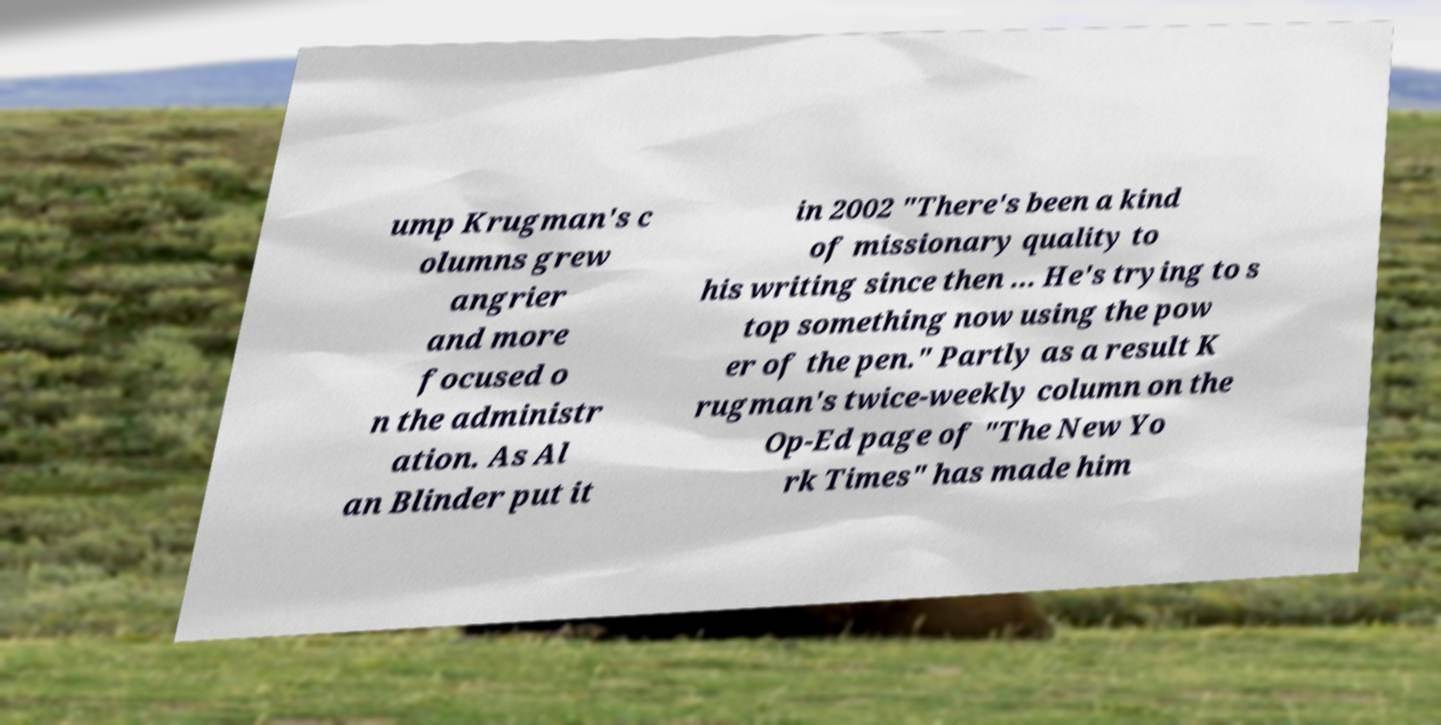Could you extract and type out the text from this image? ump Krugman's c olumns grew angrier and more focused o n the administr ation. As Al an Blinder put it in 2002 "There's been a kind of missionary quality to his writing since then ... He's trying to s top something now using the pow er of the pen." Partly as a result K rugman's twice-weekly column on the Op-Ed page of "The New Yo rk Times" has made him 